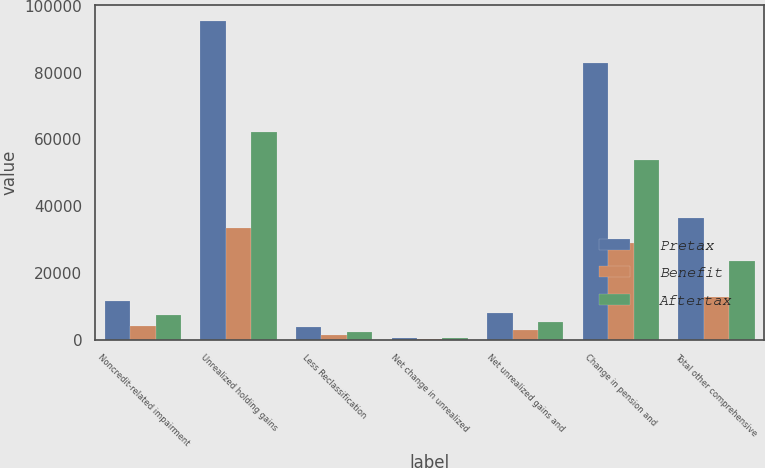Convert chart to OTSL. <chart><loc_0><loc_0><loc_500><loc_500><stacked_bar_chart><ecel><fcel>Noncredit-related impairment<fcel>Unrealized holding gains<fcel>Less Reclassification<fcel>Net change in unrealized<fcel>Net unrealized gains and<fcel>Change in pension and<fcel>Total other comprehensive<nl><fcel>Pretax<fcel>11537<fcel>95586<fcel>3681<fcel>612<fcel>7982<fcel>82885<fcel>36513<nl><fcel>Benefit<fcel>4038<fcel>33455<fcel>1288<fcel>215<fcel>2794<fcel>29010<fcel>12780<nl><fcel>Aftertax<fcel>7499<fcel>62131<fcel>2393<fcel>397<fcel>5188<fcel>53875<fcel>23733<nl></chart> 